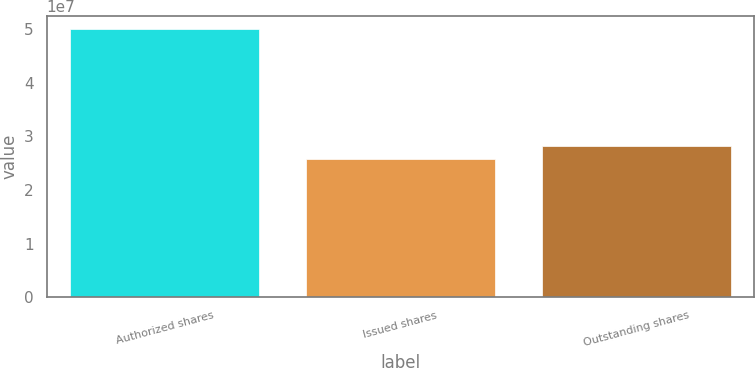Convert chart. <chart><loc_0><loc_0><loc_500><loc_500><bar_chart><fcel>Authorized shares<fcel>Issued shares<fcel>Outstanding shares<nl><fcel>5e+07<fcel>2.5875e+07<fcel>2.82875e+07<nl></chart> 